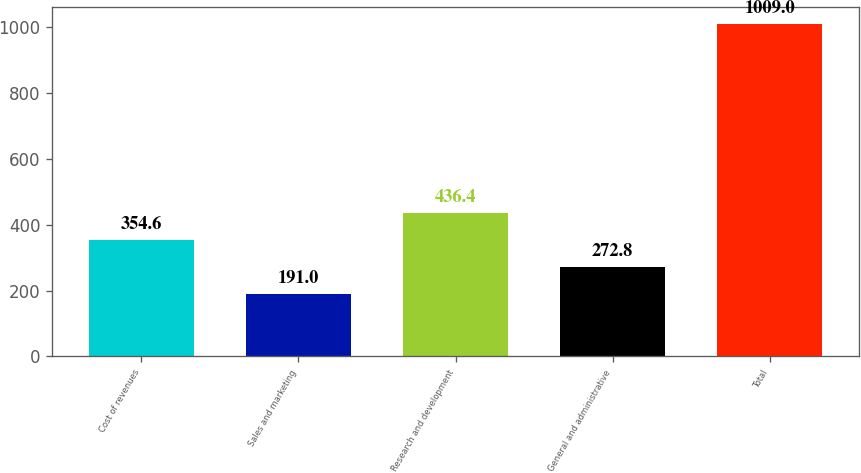Convert chart. <chart><loc_0><loc_0><loc_500><loc_500><bar_chart><fcel>Cost of revenues<fcel>Sales and marketing<fcel>Research and development<fcel>General and administrative<fcel>Total<nl><fcel>354.6<fcel>191<fcel>436.4<fcel>272.8<fcel>1009<nl></chart> 